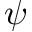Convert formula to latex. <formula><loc_0><loc_0><loc_500><loc_500>\psi</formula> 